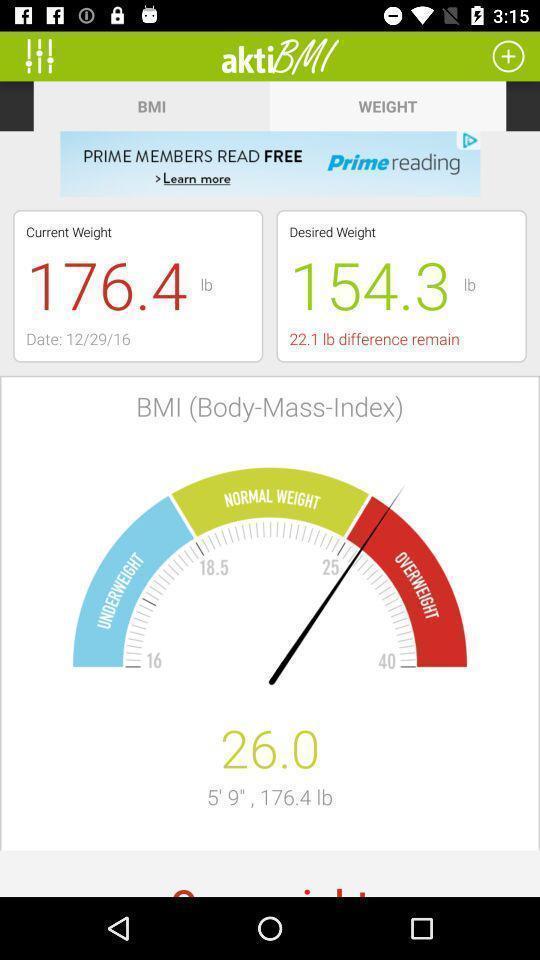Provide a description of this screenshot. Result of the weight in the app with desired suggestion. 